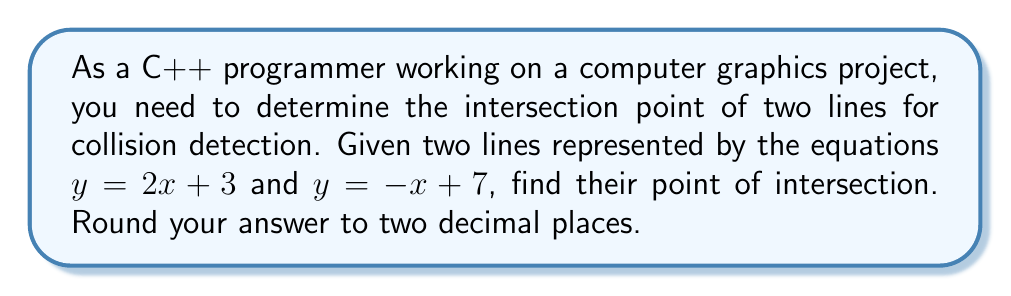Could you help me with this problem? Let's approach this step-by-step:

1) We have two linear equations:
   Line 1: $y = 2x + 3$
   Line 2: $y = -x + 7$

2) At the intersection point, the $x$ and $y$ coordinates will be the same for both lines. So we can set the right sides of the equations equal to each other:

   $2x + 3 = -x + 7$

3) Now we solve this equation for $x$:
   
   $2x + 3 = -x + 7$
   $3x = 4$
   $x = \frac{4}{3} \approx 1.33$

4) To find $y$, we can substitute this $x$ value into either of the original equations. Let's use the first one:

   $y = 2x + 3$
   $y = 2(\frac{4}{3}) + 3$
   $y = \frac{8}{3} + 3 = \frac{17}{3} \approx 5.67$

5) Therefore, the intersection point is approximately (1.33, 5.67).

6) Rounding to two decimal places, we get (1.33, 5.67).

[asy]
import geometry;

size(200);

real x = 4/3;
real y = 17/3;

draw((-1,1)--(3,7), blue);
draw((-1,5)--(3,1), red);

dot((x,y), green);

label("(1.33, 5.67)", (x,y), NE);

label("y = 2x + 3", (2,7), N, blue);
label("y = -x + 7", (-1,5), NW, red);

xaxis("x", arrow=Arrow);
yaxis("y", arrow=Arrow);
[/asy]
Answer: (1.33, 5.67) 